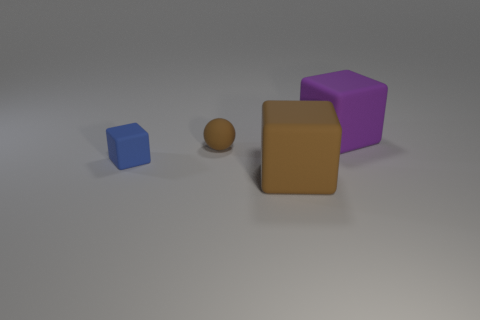Are there any other things that are the same shape as the tiny brown thing?
Offer a very short reply. No. The small brown rubber thing has what shape?
Ensure brevity in your answer.  Sphere. Are the thing that is in front of the tiny blue rubber block and the thing that is to the left of the tiny brown object made of the same material?
Keep it short and to the point. Yes. What number of matte things are the same color as the small block?
Keep it short and to the point. 0. What is the shape of the thing that is both behind the blue cube and in front of the big purple cube?
Ensure brevity in your answer.  Sphere. There is a thing that is to the right of the tiny rubber sphere and to the left of the big purple matte thing; what is its color?
Give a very brief answer. Brown. Is the number of large purple things that are behind the blue rubber object greater than the number of big brown objects that are on the left side of the small brown matte thing?
Keep it short and to the point. Yes. There is a cube to the left of the large brown object; what is its color?
Keep it short and to the point. Blue. There is a blue rubber object that is in front of the brown sphere; is it the same shape as the big matte thing to the left of the big purple object?
Provide a succinct answer. Yes. Is there a brown shiny sphere of the same size as the blue object?
Offer a terse response. No. 